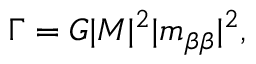Convert formula to latex. <formula><loc_0><loc_0><loc_500><loc_500>\Gamma = G | M | ^ { 2 } | m _ { \beta \beta } | ^ { 2 } ,</formula> 